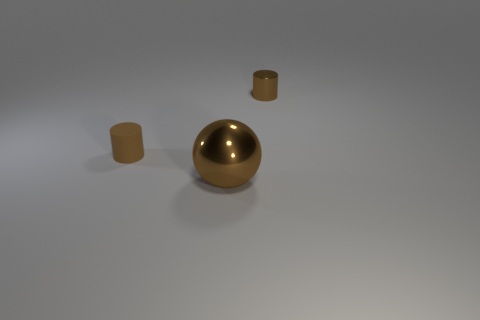Add 3 small rubber objects. How many objects exist? 6 Subtract all cylinders. How many objects are left? 1 Add 2 brown metallic cylinders. How many brown metallic cylinders are left? 3 Add 1 tiny gray rubber blocks. How many tiny gray rubber blocks exist? 1 Subtract 0 gray blocks. How many objects are left? 3 Subtract all big brown balls. Subtract all brown metallic objects. How many objects are left? 0 